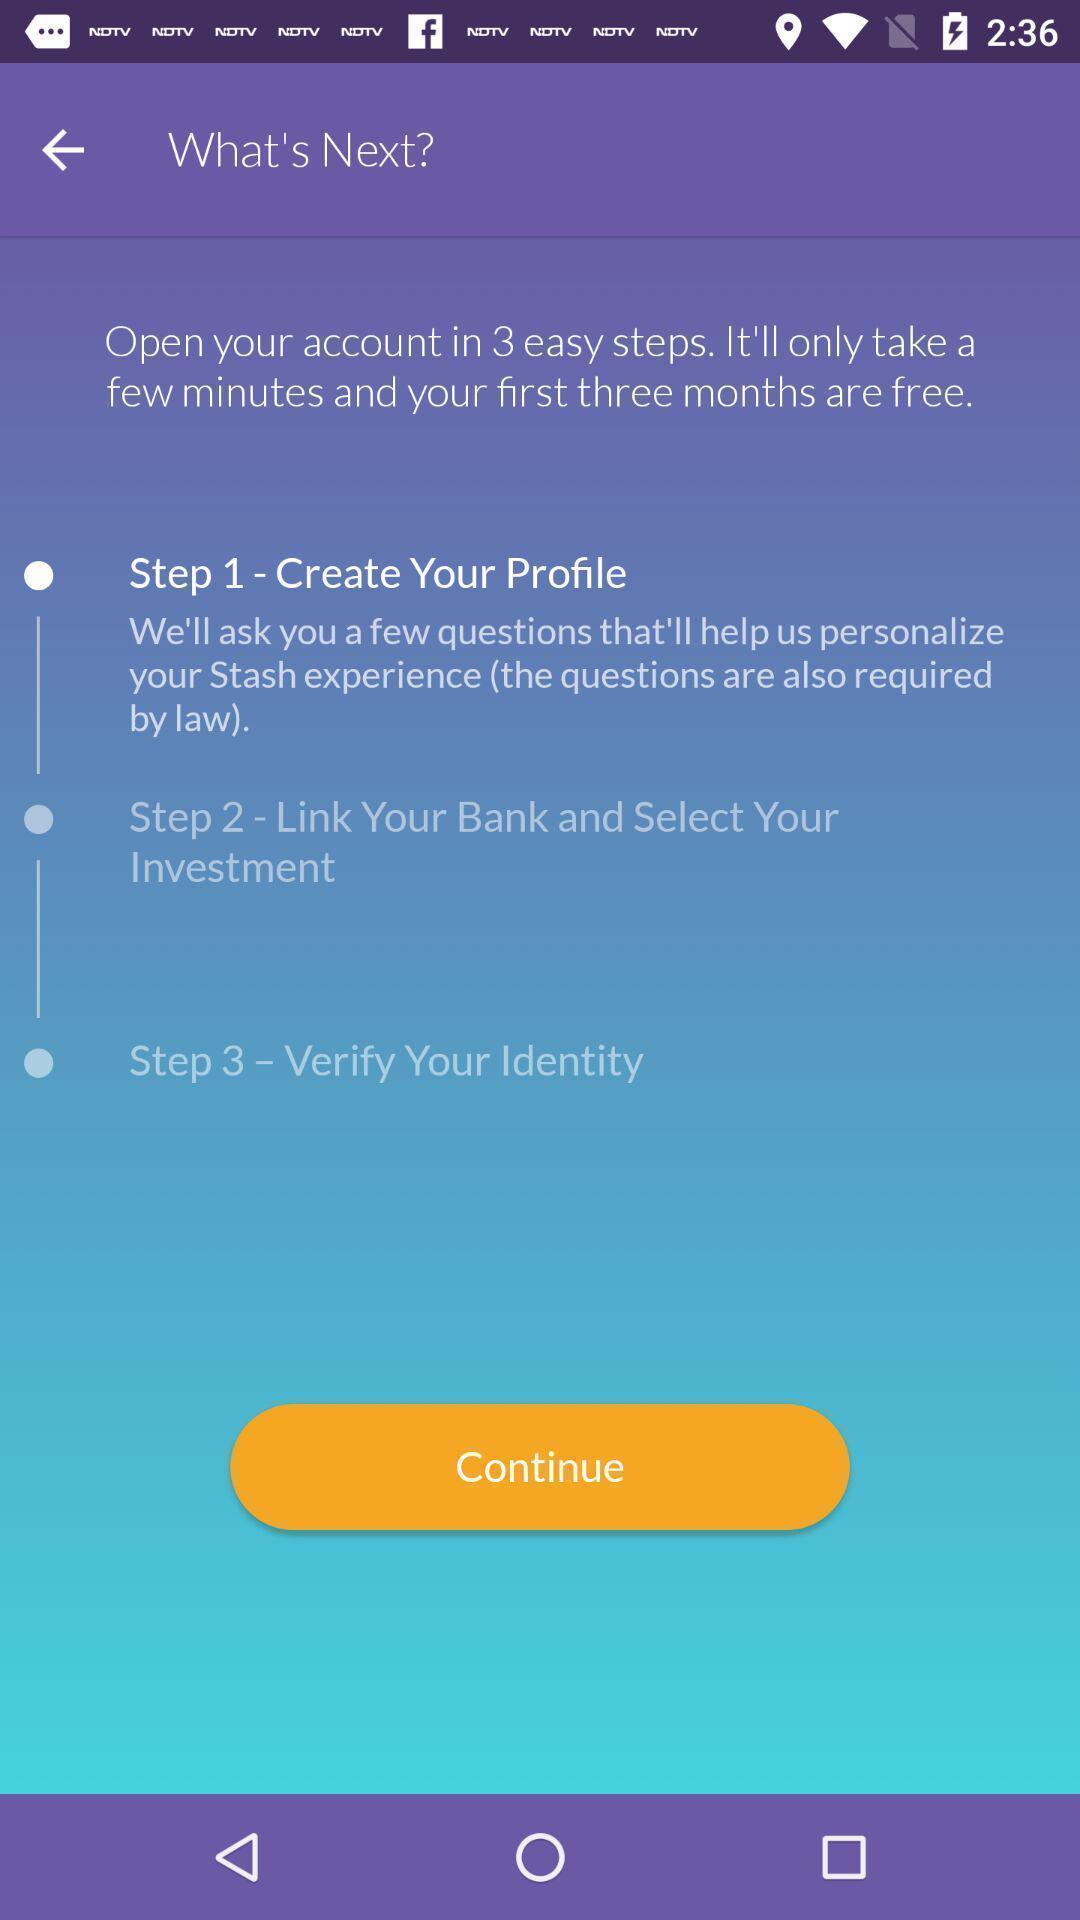What can you discern from this picture? Various steps displayed for account creation. 